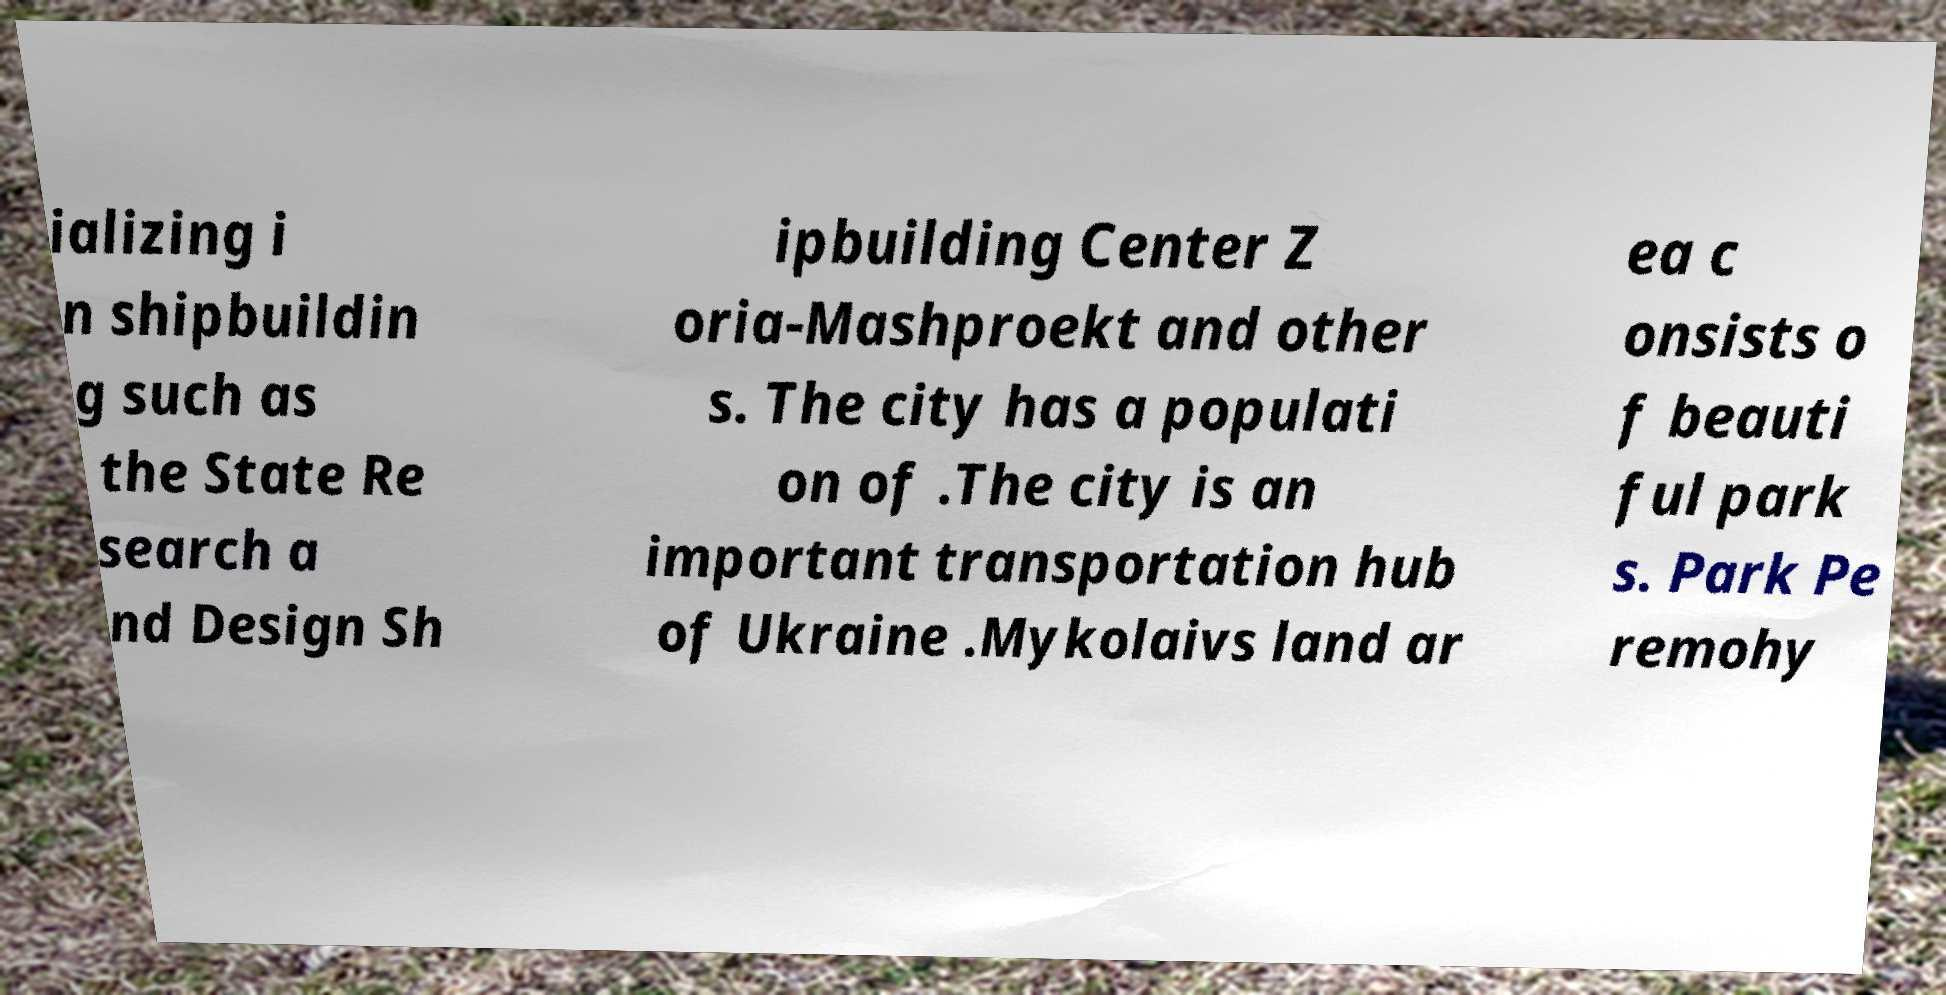For documentation purposes, I need the text within this image transcribed. Could you provide that? ializing i n shipbuildin g such as the State Re search a nd Design Sh ipbuilding Center Z oria-Mashproekt and other s. The city has a populati on of .The city is an important transportation hub of Ukraine .Mykolaivs land ar ea c onsists o f beauti ful park s. Park Pe remohy 